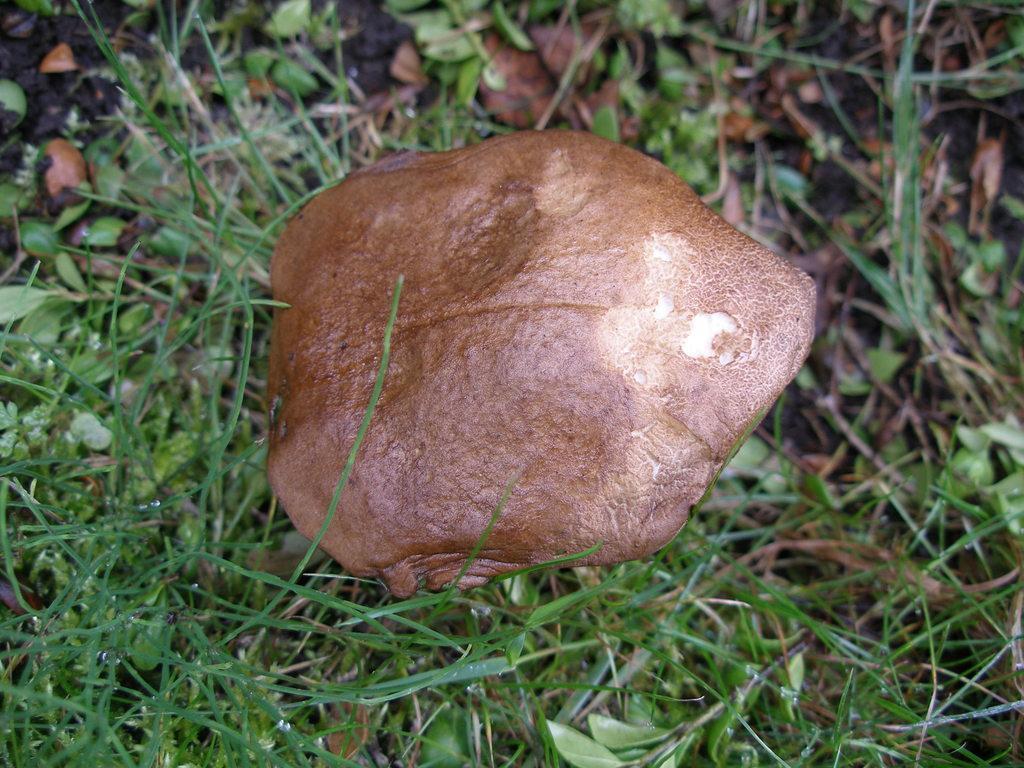Describe this image in one or two sentences. In this image, we can see some grass and leaves. There is a mushroom in the middle of the image. 